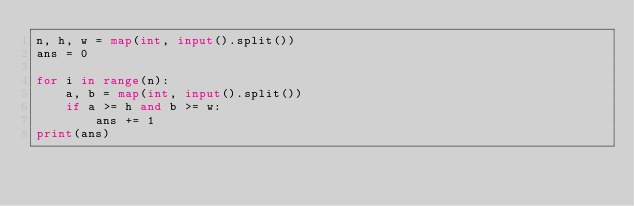Convert code to text. <code><loc_0><loc_0><loc_500><loc_500><_Python_>n, h, w = map(int, input().split())
ans = 0

for i in range(n):
    a, b = map(int, input().split())
    if a >= h and b >= w:
        ans += 1
print(ans)</code> 